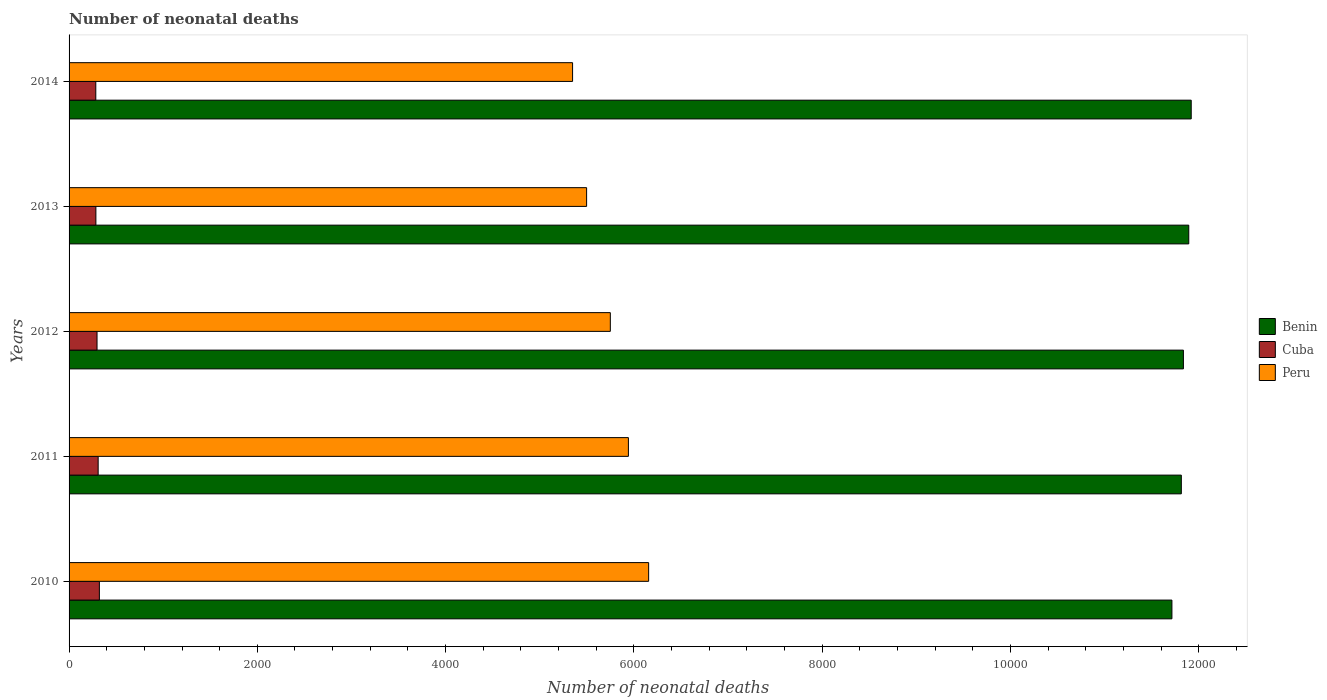Are the number of bars on each tick of the Y-axis equal?
Give a very brief answer. Yes. What is the label of the 5th group of bars from the top?
Offer a very short reply. 2010. In how many cases, is the number of bars for a given year not equal to the number of legend labels?
Offer a very short reply. 0. What is the number of neonatal deaths in in Peru in 2013?
Offer a terse response. 5498. Across all years, what is the maximum number of neonatal deaths in in Benin?
Your response must be concise. 1.19e+04. Across all years, what is the minimum number of neonatal deaths in in Cuba?
Your answer should be very brief. 284. In which year was the number of neonatal deaths in in Cuba maximum?
Offer a very short reply. 2010. What is the total number of neonatal deaths in in Benin in the graph?
Offer a terse response. 5.92e+04. What is the difference between the number of neonatal deaths in in Benin in 2010 and that in 2012?
Your answer should be compact. -122. What is the difference between the number of neonatal deaths in in Peru in 2010 and the number of neonatal deaths in in Cuba in 2012?
Your answer should be compact. 5860. What is the average number of neonatal deaths in in Benin per year?
Keep it short and to the point. 1.18e+04. In the year 2014, what is the difference between the number of neonatal deaths in in Peru and number of neonatal deaths in in Cuba?
Provide a succinct answer. 5065. What is the ratio of the number of neonatal deaths in in Benin in 2013 to that in 2014?
Give a very brief answer. 1. What is the difference between the highest and the lowest number of neonatal deaths in in Benin?
Ensure brevity in your answer.  205. Is the sum of the number of neonatal deaths in in Benin in 2010 and 2014 greater than the maximum number of neonatal deaths in in Peru across all years?
Offer a terse response. Yes. What does the 2nd bar from the top in 2014 represents?
Your response must be concise. Cuba. What does the 2nd bar from the bottom in 2011 represents?
Offer a very short reply. Cuba. Is it the case that in every year, the sum of the number of neonatal deaths in in Peru and number of neonatal deaths in in Benin is greater than the number of neonatal deaths in in Cuba?
Offer a very short reply. Yes. How many bars are there?
Provide a short and direct response. 15. How many years are there in the graph?
Provide a short and direct response. 5. Does the graph contain grids?
Offer a very short reply. No. Where does the legend appear in the graph?
Your answer should be compact. Center right. How many legend labels are there?
Keep it short and to the point. 3. How are the legend labels stacked?
Make the answer very short. Vertical. What is the title of the graph?
Give a very brief answer. Number of neonatal deaths. Does "North America" appear as one of the legend labels in the graph?
Ensure brevity in your answer.  No. What is the label or title of the X-axis?
Keep it short and to the point. Number of neonatal deaths. What is the Number of neonatal deaths of Benin in 2010?
Offer a terse response. 1.17e+04. What is the Number of neonatal deaths of Cuba in 2010?
Ensure brevity in your answer.  322. What is the Number of neonatal deaths in Peru in 2010?
Give a very brief answer. 6157. What is the Number of neonatal deaths in Benin in 2011?
Offer a very short reply. 1.18e+04. What is the Number of neonatal deaths in Cuba in 2011?
Your response must be concise. 309. What is the Number of neonatal deaths in Peru in 2011?
Offer a terse response. 5942. What is the Number of neonatal deaths in Benin in 2012?
Your answer should be very brief. 1.18e+04. What is the Number of neonatal deaths of Cuba in 2012?
Offer a very short reply. 297. What is the Number of neonatal deaths of Peru in 2012?
Provide a short and direct response. 5750. What is the Number of neonatal deaths in Benin in 2013?
Your answer should be very brief. 1.19e+04. What is the Number of neonatal deaths in Cuba in 2013?
Provide a succinct answer. 285. What is the Number of neonatal deaths in Peru in 2013?
Offer a terse response. 5498. What is the Number of neonatal deaths of Benin in 2014?
Offer a very short reply. 1.19e+04. What is the Number of neonatal deaths of Cuba in 2014?
Ensure brevity in your answer.  284. What is the Number of neonatal deaths in Peru in 2014?
Make the answer very short. 5349. Across all years, what is the maximum Number of neonatal deaths in Benin?
Provide a succinct answer. 1.19e+04. Across all years, what is the maximum Number of neonatal deaths of Cuba?
Your response must be concise. 322. Across all years, what is the maximum Number of neonatal deaths in Peru?
Provide a short and direct response. 6157. Across all years, what is the minimum Number of neonatal deaths in Benin?
Offer a very short reply. 1.17e+04. Across all years, what is the minimum Number of neonatal deaths of Cuba?
Keep it short and to the point. 284. Across all years, what is the minimum Number of neonatal deaths of Peru?
Provide a short and direct response. 5349. What is the total Number of neonatal deaths of Benin in the graph?
Offer a terse response. 5.92e+04. What is the total Number of neonatal deaths of Cuba in the graph?
Offer a terse response. 1497. What is the total Number of neonatal deaths in Peru in the graph?
Provide a short and direct response. 2.87e+04. What is the difference between the Number of neonatal deaths of Benin in 2010 and that in 2011?
Your response must be concise. -100. What is the difference between the Number of neonatal deaths of Peru in 2010 and that in 2011?
Ensure brevity in your answer.  215. What is the difference between the Number of neonatal deaths of Benin in 2010 and that in 2012?
Offer a very short reply. -122. What is the difference between the Number of neonatal deaths of Cuba in 2010 and that in 2012?
Your response must be concise. 25. What is the difference between the Number of neonatal deaths in Peru in 2010 and that in 2012?
Provide a succinct answer. 407. What is the difference between the Number of neonatal deaths of Benin in 2010 and that in 2013?
Provide a short and direct response. -179. What is the difference between the Number of neonatal deaths in Cuba in 2010 and that in 2013?
Ensure brevity in your answer.  37. What is the difference between the Number of neonatal deaths in Peru in 2010 and that in 2013?
Offer a terse response. 659. What is the difference between the Number of neonatal deaths in Benin in 2010 and that in 2014?
Keep it short and to the point. -205. What is the difference between the Number of neonatal deaths in Peru in 2010 and that in 2014?
Offer a very short reply. 808. What is the difference between the Number of neonatal deaths of Benin in 2011 and that in 2012?
Keep it short and to the point. -22. What is the difference between the Number of neonatal deaths of Peru in 2011 and that in 2012?
Offer a terse response. 192. What is the difference between the Number of neonatal deaths of Benin in 2011 and that in 2013?
Ensure brevity in your answer.  -79. What is the difference between the Number of neonatal deaths of Cuba in 2011 and that in 2013?
Provide a succinct answer. 24. What is the difference between the Number of neonatal deaths of Peru in 2011 and that in 2013?
Keep it short and to the point. 444. What is the difference between the Number of neonatal deaths in Benin in 2011 and that in 2014?
Your response must be concise. -105. What is the difference between the Number of neonatal deaths of Peru in 2011 and that in 2014?
Keep it short and to the point. 593. What is the difference between the Number of neonatal deaths in Benin in 2012 and that in 2013?
Provide a succinct answer. -57. What is the difference between the Number of neonatal deaths in Peru in 2012 and that in 2013?
Ensure brevity in your answer.  252. What is the difference between the Number of neonatal deaths of Benin in 2012 and that in 2014?
Make the answer very short. -83. What is the difference between the Number of neonatal deaths in Peru in 2012 and that in 2014?
Provide a short and direct response. 401. What is the difference between the Number of neonatal deaths of Benin in 2013 and that in 2014?
Your answer should be compact. -26. What is the difference between the Number of neonatal deaths in Peru in 2013 and that in 2014?
Provide a succinct answer. 149. What is the difference between the Number of neonatal deaths in Benin in 2010 and the Number of neonatal deaths in Cuba in 2011?
Ensure brevity in your answer.  1.14e+04. What is the difference between the Number of neonatal deaths in Benin in 2010 and the Number of neonatal deaths in Peru in 2011?
Provide a succinct answer. 5774. What is the difference between the Number of neonatal deaths of Cuba in 2010 and the Number of neonatal deaths of Peru in 2011?
Make the answer very short. -5620. What is the difference between the Number of neonatal deaths of Benin in 2010 and the Number of neonatal deaths of Cuba in 2012?
Offer a terse response. 1.14e+04. What is the difference between the Number of neonatal deaths in Benin in 2010 and the Number of neonatal deaths in Peru in 2012?
Ensure brevity in your answer.  5966. What is the difference between the Number of neonatal deaths in Cuba in 2010 and the Number of neonatal deaths in Peru in 2012?
Provide a succinct answer. -5428. What is the difference between the Number of neonatal deaths of Benin in 2010 and the Number of neonatal deaths of Cuba in 2013?
Your answer should be very brief. 1.14e+04. What is the difference between the Number of neonatal deaths of Benin in 2010 and the Number of neonatal deaths of Peru in 2013?
Ensure brevity in your answer.  6218. What is the difference between the Number of neonatal deaths in Cuba in 2010 and the Number of neonatal deaths in Peru in 2013?
Your answer should be very brief. -5176. What is the difference between the Number of neonatal deaths of Benin in 2010 and the Number of neonatal deaths of Cuba in 2014?
Give a very brief answer. 1.14e+04. What is the difference between the Number of neonatal deaths of Benin in 2010 and the Number of neonatal deaths of Peru in 2014?
Provide a succinct answer. 6367. What is the difference between the Number of neonatal deaths in Cuba in 2010 and the Number of neonatal deaths in Peru in 2014?
Give a very brief answer. -5027. What is the difference between the Number of neonatal deaths of Benin in 2011 and the Number of neonatal deaths of Cuba in 2012?
Your answer should be very brief. 1.15e+04. What is the difference between the Number of neonatal deaths of Benin in 2011 and the Number of neonatal deaths of Peru in 2012?
Ensure brevity in your answer.  6066. What is the difference between the Number of neonatal deaths of Cuba in 2011 and the Number of neonatal deaths of Peru in 2012?
Keep it short and to the point. -5441. What is the difference between the Number of neonatal deaths of Benin in 2011 and the Number of neonatal deaths of Cuba in 2013?
Offer a very short reply. 1.15e+04. What is the difference between the Number of neonatal deaths in Benin in 2011 and the Number of neonatal deaths in Peru in 2013?
Offer a terse response. 6318. What is the difference between the Number of neonatal deaths of Cuba in 2011 and the Number of neonatal deaths of Peru in 2013?
Offer a terse response. -5189. What is the difference between the Number of neonatal deaths of Benin in 2011 and the Number of neonatal deaths of Cuba in 2014?
Your response must be concise. 1.15e+04. What is the difference between the Number of neonatal deaths of Benin in 2011 and the Number of neonatal deaths of Peru in 2014?
Ensure brevity in your answer.  6467. What is the difference between the Number of neonatal deaths in Cuba in 2011 and the Number of neonatal deaths in Peru in 2014?
Your response must be concise. -5040. What is the difference between the Number of neonatal deaths in Benin in 2012 and the Number of neonatal deaths in Cuba in 2013?
Offer a very short reply. 1.16e+04. What is the difference between the Number of neonatal deaths in Benin in 2012 and the Number of neonatal deaths in Peru in 2013?
Offer a very short reply. 6340. What is the difference between the Number of neonatal deaths in Cuba in 2012 and the Number of neonatal deaths in Peru in 2013?
Provide a succinct answer. -5201. What is the difference between the Number of neonatal deaths of Benin in 2012 and the Number of neonatal deaths of Cuba in 2014?
Ensure brevity in your answer.  1.16e+04. What is the difference between the Number of neonatal deaths of Benin in 2012 and the Number of neonatal deaths of Peru in 2014?
Keep it short and to the point. 6489. What is the difference between the Number of neonatal deaths of Cuba in 2012 and the Number of neonatal deaths of Peru in 2014?
Your response must be concise. -5052. What is the difference between the Number of neonatal deaths of Benin in 2013 and the Number of neonatal deaths of Cuba in 2014?
Make the answer very short. 1.16e+04. What is the difference between the Number of neonatal deaths of Benin in 2013 and the Number of neonatal deaths of Peru in 2014?
Make the answer very short. 6546. What is the difference between the Number of neonatal deaths of Cuba in 2013 and the Number of neonatal deaths of Peru in 2014?
Provide a succinct answer. -5064. What is the average Number of neonatal deaths of Benin per year?
Keep it short and to the point. 1.18e+04. What is the average Number of neonatal deaths of Cuba per year?
Your answer should be very brief. 299.4. What is the average Number of neonatal deaths in Peru per year?
Provide a succinct answer. 5739.2. In the year 2010, what is the difference between the Number of neonatal deaths of Benin and Number of neonatal deaths of Cuba?
Provide a short and direct response. 1.14e+04. In the year 2010, what is the difference between the Number of neonatal deaths in Benin and Number of neonatal deaths in Peru?
Your answer should be compact. 5559. In the year 2010, what is the difference between the Number of neonatal deaths in Cuba and Number of neonatal deaths in Peru?
Your answer should be very brief. -5835. In the year 2011, what is the difference between the Number of neonatal deaths of Benin and Number of neonatal deaths of Cuba?
Offer a terse response. 1.15e+04. In the year 2011, what is the difference between the Number of neonatal deaths of Benin and Number of neonatal deaths of Peru?
Make the answer very short. 5874. In the year 2011, what is the difference between the Number of neonatal deaths of Cuba and Number of neonatal deaths of Peru?
Offer a terse response. -5633. In the year 2012, what is the difference between the Number of neonatal deaths of Benin and Number of neonatal deaths of Cuba?
Offer a very short reply. 1.15e+04. In the year 2012, what is the difference between the Number of neonatal deaths of Benin and Number of neonatal deaths of Peru?
Offer a terse response. 6088. In the year 2012, what is the difference between the Number of neonatal deaths in Cuba and Number of neonatal deaths in Peru?
Provide a short and direct response. -5453. In the year 2013, what is the difference between the Number of neonatal deaths in Benin and Number of neonatal deaths in Cuba?
Offer a terse response. 1.16e+04. In the year 2013, what is the difference between the Number of neonatal deaths in Benin and Number of neonatal deaths in Peru?
Make the answer very short. 6397. In the year 2013, what is the difference between the Number of neonatal deaths of Cuba and Number of neonatal deaths of Peru?
Provide a succinct answer. -5213. In the year 2014, what is the difference between the Number of neonatal deaths of Benin and Number of neonatal deaths of Cuba?
Keep it short and to the point. 1.16e+04. In the year 2014, what is the difference between the Number of neonatal deaths of Benin and Number of neonatal deaths of Peru?
Your answer should be compact. 6572. In the year 2014, what is the difference between the Number of neonatal deaths of Cuba and Number of neonatal deaths of Peru?
Ensure brevity in your answer.  -5065. What is the ratio of the Number of neonatal deaths in Benin in 2010 to that in 2011?
Keep it short and to the point. 0.99. What is the ratio of the Number of neonatal deaths in Cuba in 2010 to that in 2011?
Provide a succinct answer. 1.04. What is the ratio of the Number of neonatal deaths of Peru in 2010 to that in 2011?
Provide a succinct answer. 1.04. What is the ratio of the Number of neonatal deaths of Benin in 2010 to that in 2012?
Ensure brevity in your answer.  0.99. What is the ratio of the Number of neonatal deaths of Cuba in 2010 to that in 2012?
Give a very brief answer. 1.08. What is the ratio of the Number of neonatal deaths in Peru in 2010 to that in 2012?
Provide a short and direct response. 1.07. What is the ratio of the Number of neonatal deaths of Cuba in 2010 to that in 2013?
Offer a terse response. 1.13. What is the ratio of the Number of neonatal deaths in Peru in 2010 to that in 2013?
Ensure brevity in your answer.  1.12. What is the ratio of the Number of neonatal deaths of Benin in 2010 to that in 2014?
Your response must be concise. 0.98. What is the ratio of the Number of neonatal deaths of Cuba in 2010 to that in 2014?
Offer a terse response. 1.13. What is the ratio of the Number of neonatal deaths of Peru in 2010 to that in 2014?
Provide a succinct answer. 1.15. What is the ratio of the Number of neonatal deaths of Cuba in 2011 to that in 2012?
Make the answer very short. 1.04. What is the ratio of the Number of neonatal deaths of Peru in 2011 to that in 2012?
Give a very brief answer. 1.03. What is the ratio of the Number of neonatal deaths in Benin in 2011 to that in 2013?
Make the answer very short. 0.99. What is the ratio of the Number of neonatal deaths in Cuba in 2011 to that in 2013?
Provide a short and direct response. 1.08. What is the ratio of the Number of neonatal deaths of Peru in 2011 to that in 2013?
Your response must be concise. 1.08. What is the ratio of the Number of neonatal deaths of Benin in 2011 to that in 2014?
Keep it short and to the point. 0.99. What is the ratio of the Number of neonatal deaths of Cuba in 2011 to that in 2014?
Provide a succinct answer. 1.09. What is the ratio of the Number of neonatal deaths of Peru in 2011 to that in 2014?
Your response must be concise. 1.11. What is the ratio of the Number of neonatal deaths in Benin in 2012 to that in 2013?
Your response must be concise. 1. What is the ratio of the Number of neonatal deaths in Cuba in 2012 to that in 2013?
Keep it short and to the point. 1.04. What is the ratio of the Number of neonatal deaths in Peru in 2012 to that in 2013?
Give a very brief answer. 1.05. What is the ratio of the Number of neonatal deaths in Benin in 2012 to that in 2014?
Your answer should be very brief. 0.99. What is the ratio of the Number of neonatal deaths of Cuba in 2012 to that in 2014?
Make the answer very short. 1.05. What is the ratio of the Number of neonatal deaths of Peru in 2012 to that in 2014?
Keep it short and to the point. 1.07. What is the ratio of the Number of neonatal deaths of Benin in 2013 to that in 2014?
Keep it short and to the point. 1. What is the ratio of the Number of neonatal deaths of Cuba in 2013 to that in 2014?
Make the answer very short. 1. What is the ratio of the Number of neonatal deaths in Peru in 2013 to that in 2014?
Your response must be concise. 1.03. What is the difference between the highest and the second highest Number of neonatal deaths of Peru?
Your answer should be very brief. 215. What is the difference between the highest and the lowest Number of neonatal deaths in Benin?
Provide a succinct answer. 205. What is the difference between the highest and the lowest Number of neonatal deaths in Peru?
Give a very brief answer. 808. 